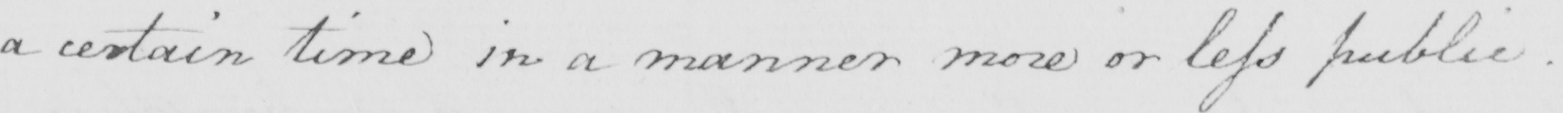What does this handwritten line say? a certain time in a manner more or less public . 